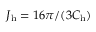<formula> <loc_0><loc_0><loc_500><loc_500>J _ { h } = 1 6 \pi / ( 3 C _ { h } )</formula> 